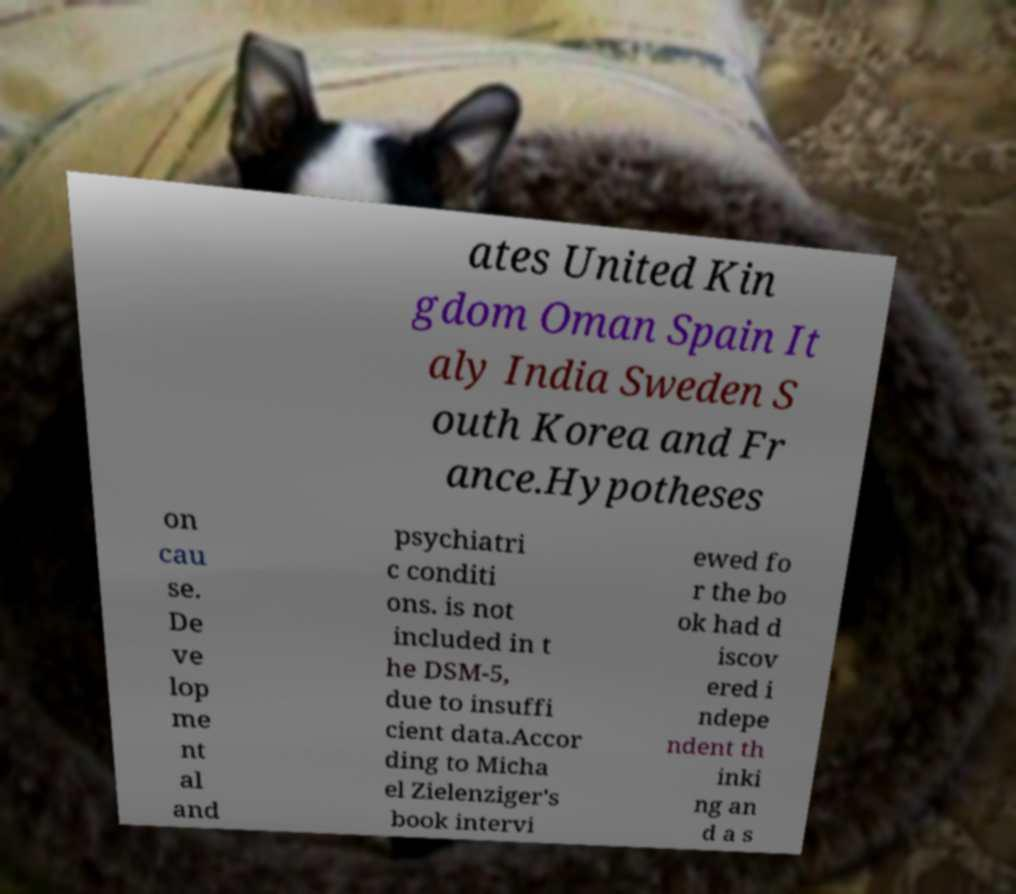I need the written content from this picture converted into text. Can you do that? ates United Kin gdom Oman Spain It aly India Sweden S outh Korea and Fr ance.Hypotheses on cau se. De ve lop me nt al and psychiatri c conditi ons. is not included in t he DSM-5, due to insuffi cient data.Accor ding to Micha el Zielenziger's book intervi ewed fo r the bo ok had d iscov ered i ndepe ndent th inki ng an d a s 